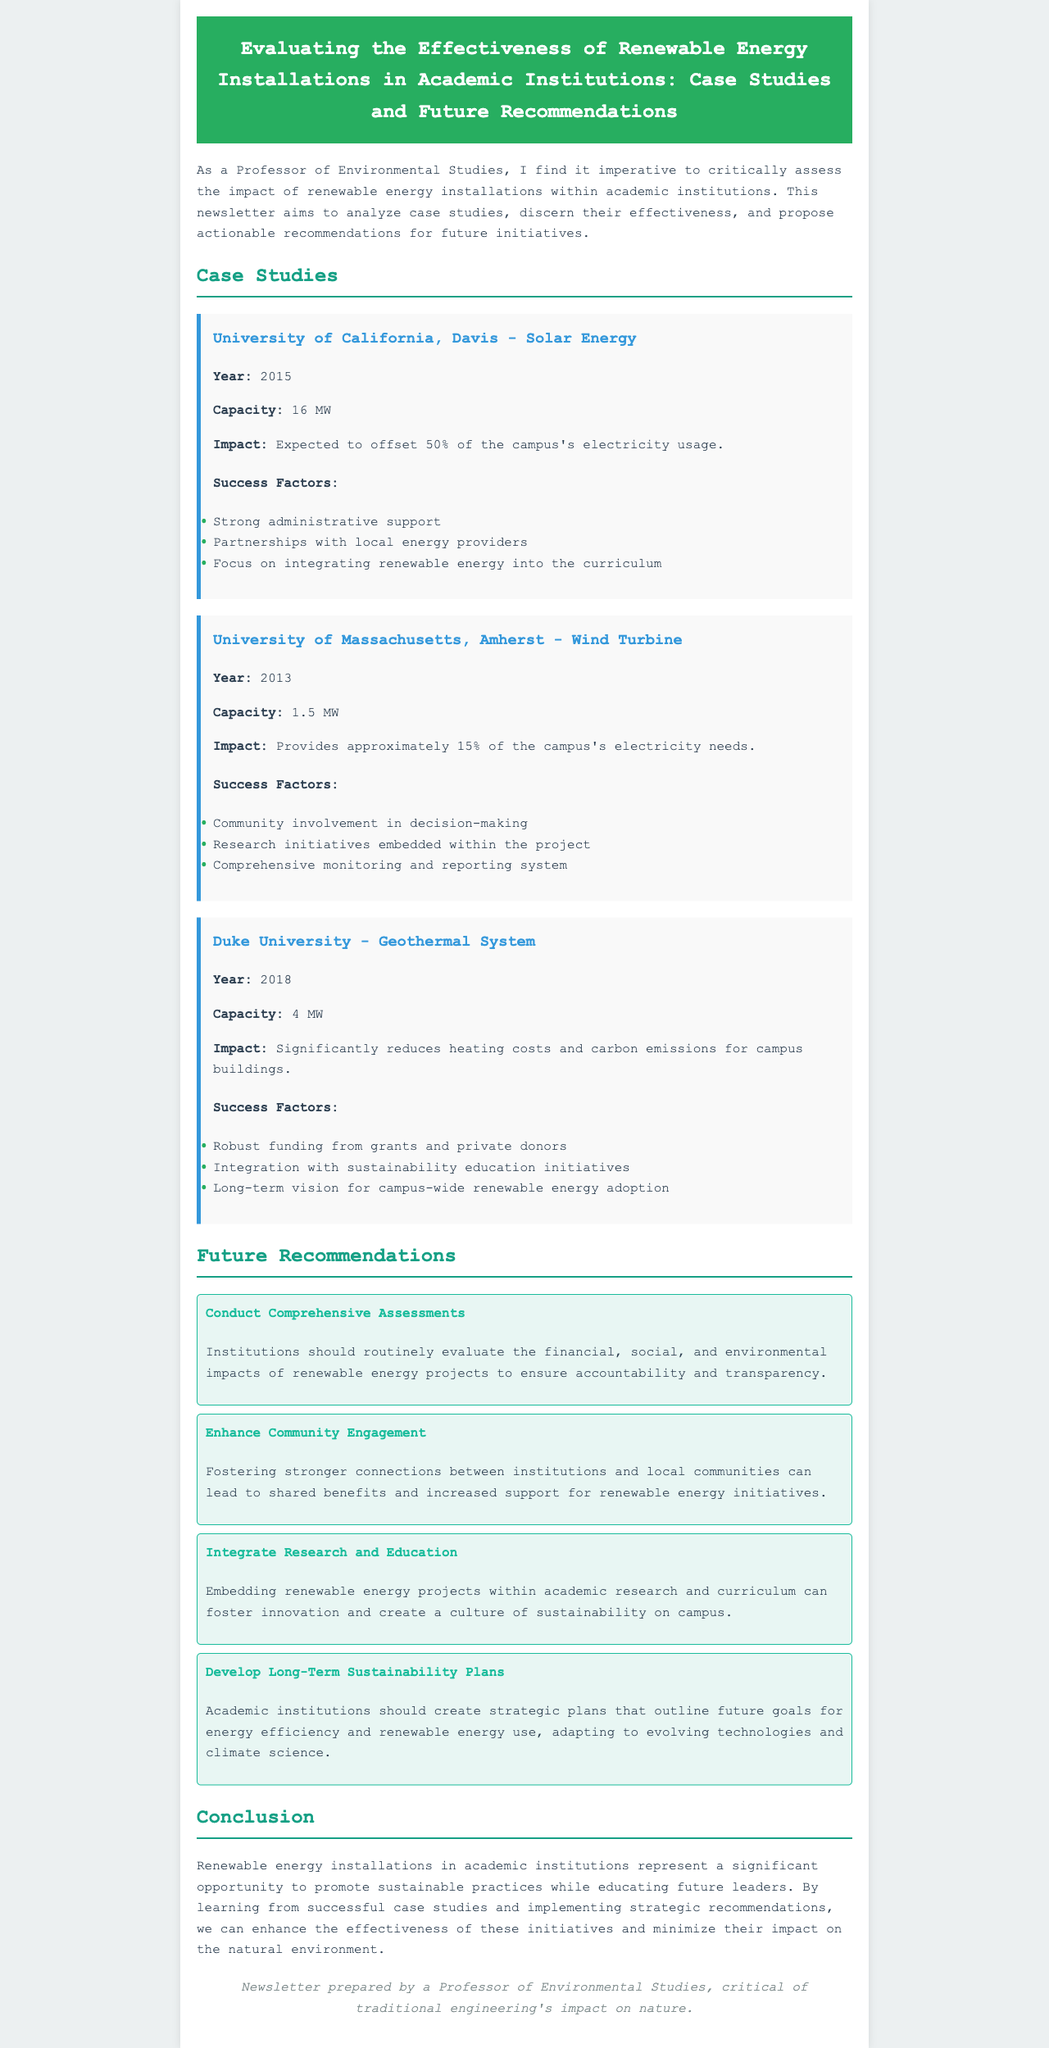What is the capacity of the solar energy installation at UC Davis? The capacity is stated in the case study section where it mentions the solar energy installation's specifications.
Answer: 16 MW What percentage of electricity usage does the solar energy at UC Davis offset? The document specifies in the impact section of the case study that it offsets a particular percentage of electricity usage.
Answer: 50% In what year was the wind turbine at the University of Massachusetts Amherst installed? The year is directly mentioned in the case study for the University of Massachusetts Amherst's wind turbine.
Answer: 2013 What is a main success factor for Duke University's geothermal system? The document lists a few success factors for the geothermal system in the case study section, allowing me to identify a notable one.
Answer: Robust funding from grants and private donors What type of energy project is discussed in the case study of Duke University? By looking at the specific focus of the case study, I can identify the type of renewable energy project at Duke University.
Answer: Geothermal system How should institutions evaluate renewable energy projects according to the recommendations? The recommendations section outlines several future actions that institutions should take regarding assessment, which I can summarize from that information.
Answer: Conduct Comprehensive Assessments What is one aspect of enhancing community engagement, as mentioned in the recommendations? By synthesizing information from the recommendations section, I can pinpoint a primary goal of enhancing community engagement efforts.
Answer: Foster stronger connections between institutions and local communities What is a key focus area of the newsletter? The introduction provides insight into the core aim of the write-up by summarizing its intended focus area.
Answer: Analyzing case studies What is the last focus mentioned in the conclusion regarding renewable energy installations? The conclusion discusses the overarching theme of the impact of renewable energy installations, which I can extract from its summarized points.
Answer: Promote sustainable practices 